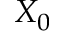Convert formula to latex. <formula><loc_0><loc_0><loc_500><loc_500>X _ { 0 }</formula> 